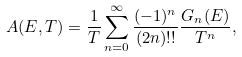<formula> <loc_0><loc_0><loc_500><loc_500>A ( E , T ) = \frac { 1 } { T } \sum _ { n = 0 } ^ { \infty } \frac { ( - 1 ) ^ { n } } { ( 2 n ) ! ! } \frac { G _ { n } ( E ) } { T ^ { n } } ,</formula> 